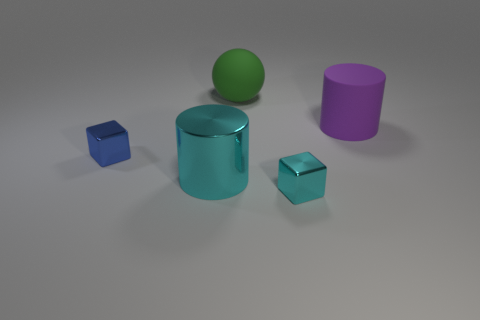Add 1 green matte objects. How many objects exist? 6 Subtract all cubes. How many objects are left? 3 Subtract 0 blue balls. How many objects are left? 5 Subtract all cubes. Subtract all spheres. How many objects are left? 2 Add 3 large cyan metal cylinders. How many large cyan metal cylinders are left? 4 Add 4 large cyan objects. How many large cyan objects exist? 5 